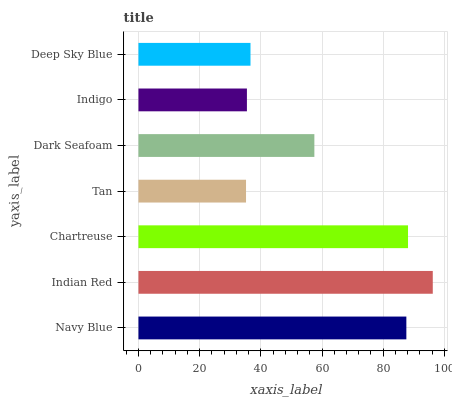Is Tan the minimum?
Answer yes or no. Yes. Is Indian Red the maximum?
Answer yes or no. Yes. Is Chartreuse the minimum?
Answer yes or no. No. Is Chartreuse the maximum?
Answer yes or no. No. Is Indian Red greater than Chartreuse?
Answer yes or no. Yes. Is Chartreuse less than Indian Red?
Answer yes or no. Yes. Is Chartreuse greater than Indian Red?
Answer yes or no. No. Is Indian Red less than Chartreuse?
Answer yes or no. No. Is Dark Seafoam the high median?
Answer yes or no. Yes. Is Dark Seafoam the low median?
Answer yes or no. Yes. Is Indian Red the high median?
Answer yes or no. No. Is Indigo the low median?
Answer yes or no. No. 